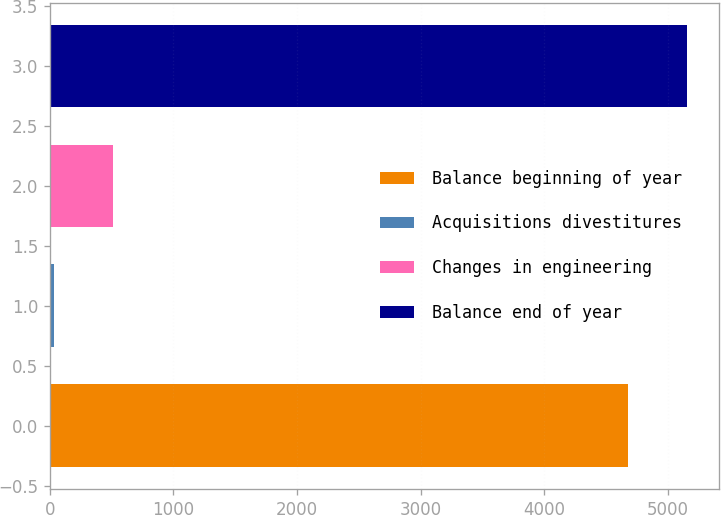Convert chart. <chart><loc_0><loc_0><loc_500><loc_500><bar_chart><fcel>Balance beginning of year<fcel>Acquisitions divestitures<fcel>Changes in engineering<fcel>Balance end of year<nl><fcel>4680<fcel>35<fcel>508.8<fcel>5153.8<nl></chart> 